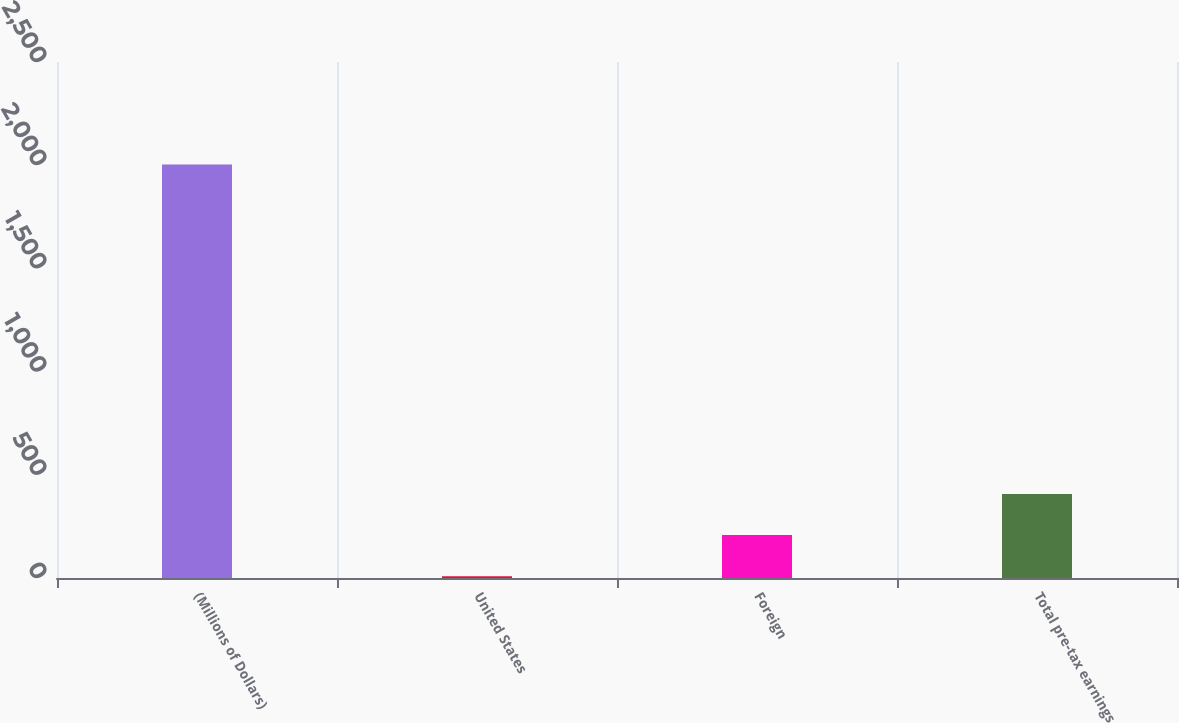Convert chart to OTSL. <chart><loc_0><loc_0><loc_500><loc_500><bar_chart><fcel>(Millions of Dollars)<fcel>United States<fcel>Foreign<fcel>Total pre-tax earnings<nl><fcel>2003<fcel>8.7<fcel>208.13<fcel>407.56<nl></chart> 